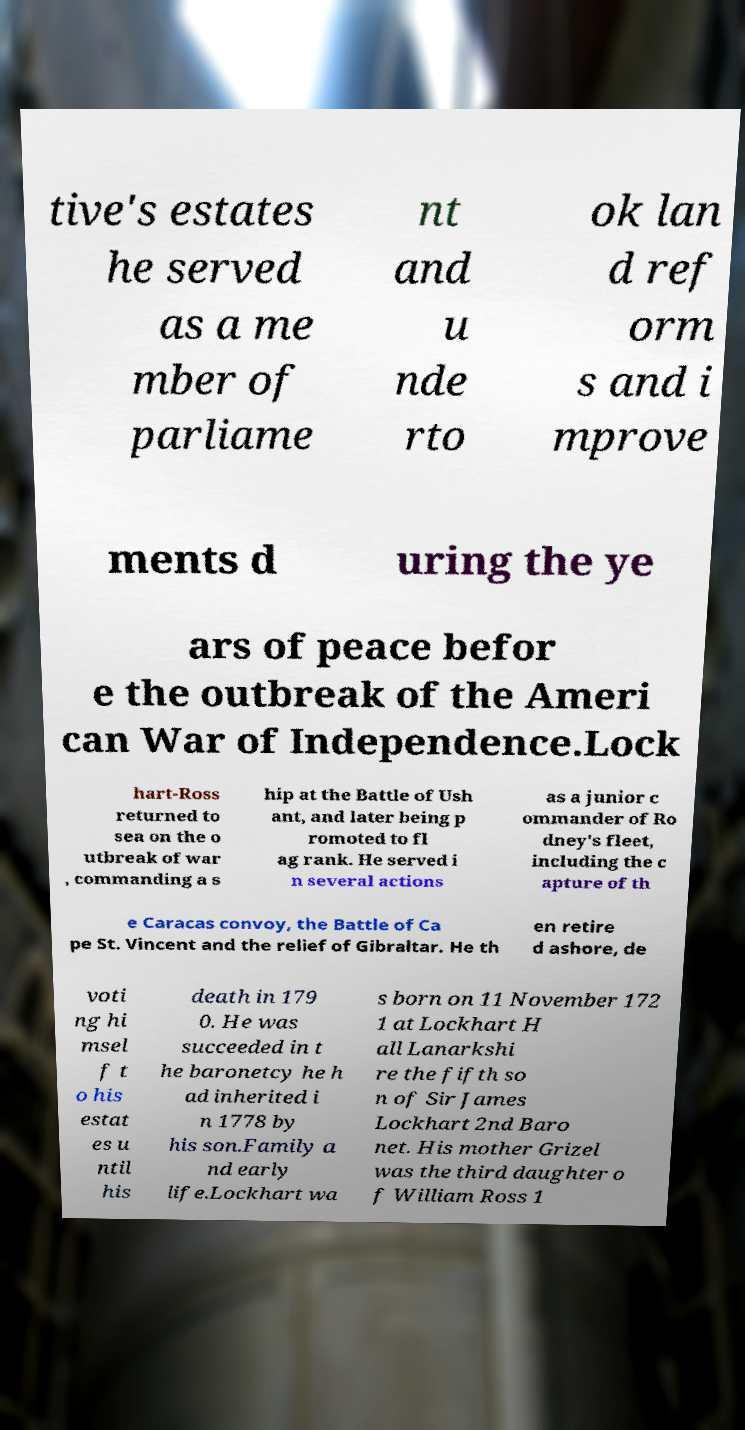Could you extract and type out the text from this image? tive's estates he served as a me mber of parliame nt and u nde rto ok lan d ref orm s and i mprove ments d uring the ye ars of peace befor e the outbreak of the Ameri can War of Independence.Lock hart-Ross returned to sea on the o utbreak of war , commanding a s hip at the Battle of Ush ant, and later being p romoted to fl ag rank. He served i n several actions as a junior c ommander of Ro dney's fleet, including the c apture of th e Caracas convoy, the Battle of Ca pe St. Vincent and the relief of Gibraltar. He th en retire d ashore, de voti ng hi msel f t o his estat es u ntil his death in 179 0. He was succeeded in t he baronetcy he h ad inherited i n 1778 by his son.Family a nd early life.Lockhart wa s born on 11 November 172 1 at Lockhart H all Lanarkshi re the fifth so n of Sir James Lockhart 2nd Baro net. His mother Grizel was the third daughter o f William Ross 1 